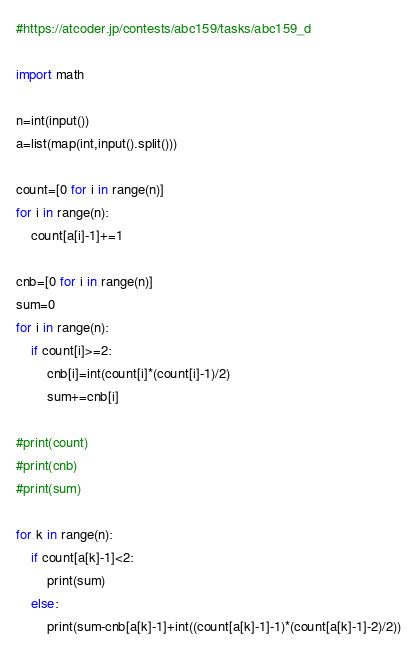Convert code to text. <code><loc_0><loc_0><loc_500><loc_500><_Python_>#https://atcoder.jp/contests/abc159/tasks/abc159_d

import math

n=int(input())
a=list(map(int,input().split()))

count=[0 for i in range(n)]
for i in range(n):
    count[a[i]-1]+=1

cnb=[0 for i in range(n)]
sum=0
for i in range(n):
    if count[i]>=2:
        cnb[i]=int(count[i]*(count[i]-1)/2)
        sum+=cnb[i]

#print(count)
#print(cnb)
#print(sum)

for k in range(n):
    if count[a[k]-1]<2:
        print(sum)
    else:
        print(sum-cnb[a[k]-1]+int((count[a[k]-1]-1)*(count[a[k]-1]-2)/2))</code> 